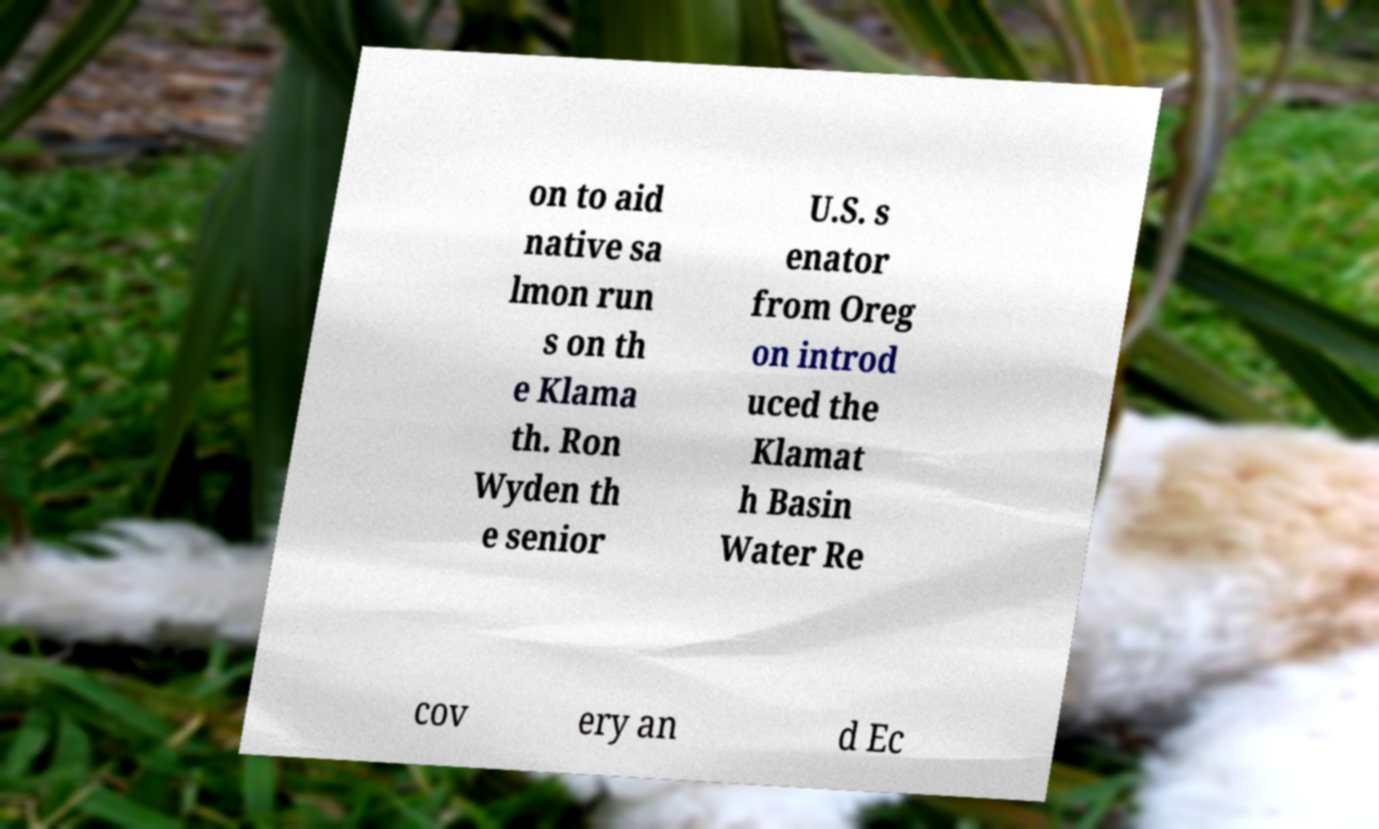Can you accurately transcribe the text from the provided image for me? on to aid native sa lmon run s on th e Klama th. Ron Wyden th e senior U.S. s enator from Oreg on introd uced the Klamat h Basin Water Re cov ery an d Ec 